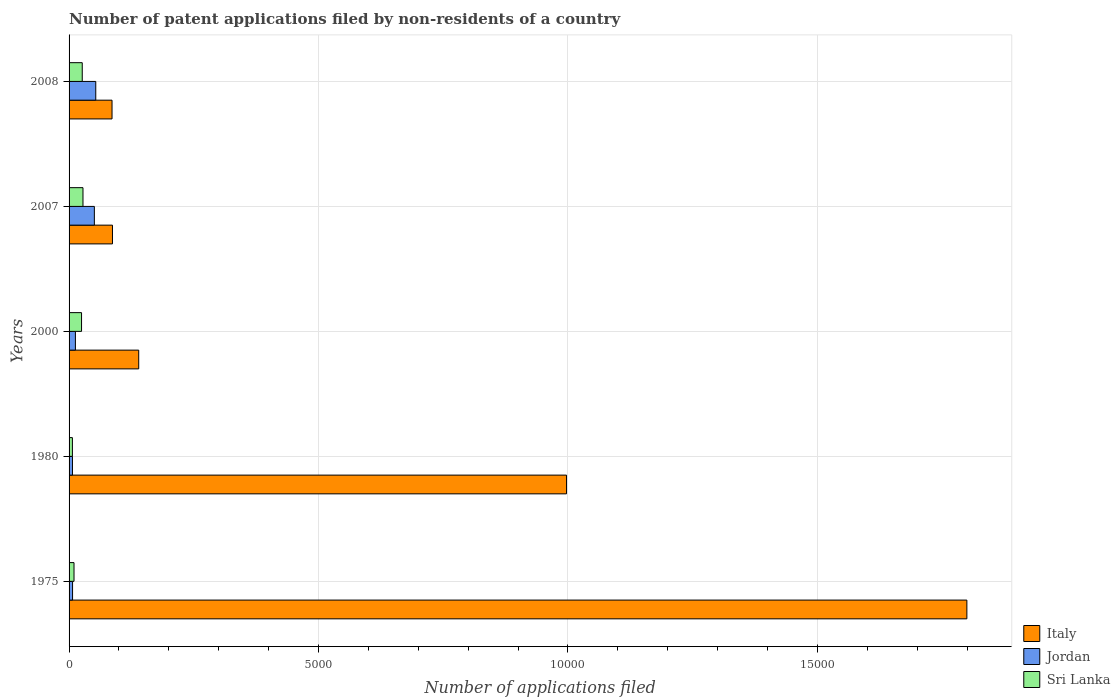How many groups of bars are there?
Ensure brevity in your answer.  5. Are the number of bars per tick equal to the number of legend labels?
Provide a short and direct response. Yes. Are the number of bars on each tick of the Y-axis equal?
Offer a very short reply. Yes. How many bars are there on the 1st tick from the top?
Provide a short and direct response. 3. How many bars are there on the 5th tick from the bottom?
Offer a terse response. 3. In how many cases, is the number of bars for a given year not equal to the number of legend labels?
Give a very brief answer. 0. What is the number of applications filed in Italy in 1980?
Give a very brief answer. 9971. Across all years, what is the maximum number of applications filed in Italy?
Offer a terse response. 1.80e+04. What is the total number of applications filed in Sri Lanka in the graph?
Provide a succinct answer. 959. What is the difference between the number of applications filed in Jordan in 1980 and that in 2007?
Offer a terse response. -439. What is the difference between the number of applications filed in Sri Lanka in 1980 and the number of applications filed in Italy in 1975?
Your answer should be very brief. -1.79e+04. What is the average number of applications filed in Sri Lanka per year?
Your answer should be very brief. 191.8. In the year 1975, what is the difference between the number of applications filed in Jordan and number of applications filed in Italy?
Give a very brief answer. -1.79e+04. In how many years, is the number of applications filed in Italy greater than 10000 ?
Your response must be concise. 1. What is the ratio of the number of applications filed in Jordan in 1975 to that in 1980?
Offer a terse response. 1.03. Is the number of applications filed in Sri Lanka in 1980 less than that in 2000?
Keep it short and to the point. Yes. What is the difference between the highest and the second highest number of applications filed in Sri Lanka?
Ensure brevity in your answer.  15. What is the difference between the highest and the lowest number of applications filed in Italy?
Your answer should be compact. 1.71e+04. In how many years, is the number of applications filed in Jordan greater than the average number of applications filed in Jordan taken over all years?
Give a very brief answer. 2. Is the sum of the number of applications filed in Sri Lanka in 2000 and 2008 greater than the maximum number of applications filed in Italy across all years?
Your response must be concise. No. What does the 2nd bar from the top in 2000 represents?
Give a very brief answer. Jordan. What does the 2nd bar from the bottom in 2007 represents?
Your answer should be very brief. Jordan. Is it the case that in every year, the sum of the number of applications filed in Jordan and number of applications filed in Italy is greater than the number of applications filed in Sri Lanka?
Ensure brevity in your answer.  Yes. How many bars are there?
Provide a short and direct response. 15. What is the difference between two consecutive major ticks on the X-axis?
Keep it short and to the point. 5000. How are the legend labels stacked?
Provide a short and direct response. Vertical. What is the title of the graph?
Provide a short and direct response. Number of patent applications filed by non-residents of a country. Does "Romania" appear as one of the legend labels in the graph?
Give a very brief answer. No. What is the label or title of the X-axis?
Make the answer very short. Number of applications filed. What is the label or title of the Y-axis?
Offer a terse response. Years. What is the Number of applications filed in Italy in 1975?
Offer a very short reply. 1.80e+04. What is the Number of applications filed in Jordan in 1975?
Provide a succinct answer. 70. What is the Number of applications filed in Italy in 1980?
Offer a terse response. 9971. What is the Number of applications filed of Sri Lanka in 1980?
Your response must be concise. 67. What is the Number of applications filed of Italy in 2000?
Provide a short and direct response. 1396. What is the Number of applications filed in Jordan in 2000?
Offer a terse response. 127. What is the Number of applications filed of Sri Lanka in 2000?
Keep it short and to the point. 250. What is the Number of applications filed in Italy in 2007?
Your answer should be compact. 870. What is the Number of applications filed in Jordan in 2007?
Your response must be concise. 507. What is the Number of applications filed of Sri Lanka in 2007?
Make the answer very short. 279. What is the Number of applications filed in Italy in 2008?
Provide a succinct answer. 861. What is the Number of applications filed of Jordan in 2008?
Offer a terse response. 535. What is the Number of applications filed of Sri Lanka in 2008?
Make the answer very short. 264. Across all years, what is the maximum Number of applications filed in Italy?
Make the answer very short. 1.80e+04. Across all years, what is the maximum Number of applications filed of Jordan?
Make the answer very short. 535. Across all years, what is the maximum Number of applications filed in Sri Lanka?
Ensure brevity in your answer.  279. Across all years, what is the minimum Number of applications filed in Italy?
Give a very brief answer. 861. Across all years, what is the minimum Number of applications filed of Jordan?
Ensure brevity in your answer.  68. What is the total Number of applications filed of Italy in the graph?
Your answer should be very brief. 3.11e+04. What is the total Number of applications filed in Jordan in the graph?
Keep it short and to the point. 1307. What is the total Number of applications filed in Sri Lanka in the graph?
Ensure brevity in your answer.  959. What is the difference between the Number of applications filed of Italy in 1975 and that in 1980?
Give a very brief answer. 8024. What is the difference between the Number of applications filed of Jordan in 1975 and that in 1980?
Keep it short and to the point. 2. What is the difference between the Number of applications filed of Italy in 1975 and that in 2000?
Your answer should be compact. 1.66e+04. What is the difference between the Number of applications filed in Jordan in 1975 and that in 2000?
Your answer should be compact. -57. What is the difference between the Number of applications filed in Sri Lanka in 1975 and that in 2000?
Your response must be concise. -151. What is the difference between the Number of applications filed of Italy in 1975 and that in 2007?
Keep it short and to the point. 1.71e+04. What is the difference between the Number of applications filed in Jordan in 1975 and that in 2007?
Your answer should be compact. -437. What is the difference between the Number of applications filed of Sri Lanka in 1975 and that in 2007?
Provide a succinct answer. -180. What is the difference between the Number of applications filed of Italy in 1975 and that in 2008?
Offer a very short reply. 1.71e+04. What is the difference between the Number of applications filed in Jordan in 1975 and that in 2008?
Offer a very short reply. -465. What is the difference between the Number of applications filed in Sri Lanka in 1975 and that in 2008?
Give a very brief answer. -165. What is the difference between the Number of applications filed of Italy in 1980 and that in 2000?
Keep it short and to the point. 8575. What is the difference between the Number of applications filed of Jordan in 1980 and that in 2000?
Provide a succinct answer. -59. What is the difference between the Number of applications filed in Sri Lanka in 1980 and that in 2000?
Keep it short and to the point. -183. What is the difference between the Number of applications filed of Italy in 1980 and that in 2007?
Your answer should be very brief. 9101. What is the difference between the Number of applications filed of Jordan in 1980 and that in 2007?
Keep it short and to the point. -439. What is the difference between the Number of applications filed in Sri Lanka in 1980 and that in 2007?
Offer a very short reply. -212. What is the difference between the Number of applications filed of Italy in 1980 and that in 2008?
Provide a succinct answer. 9110. What is the difference between the Number of applications filed of Jordan in 1980 and that in 2008?
Keep it short and to the point. -467. What is the difference between the Number of applications filed in Sri Lanka in 1980 and that in 2008?
Your response must be concise. -197. What is the difference between the Number of applications filed of Italy in 2000 and that in 2007?
Your answer should be very brief. 526. What is the difference between the Number of applications filed of Jordan in 2000 and that in 2007?
Keep it short and to the point. -380. What is the difference between the Number of applications filed in Sri Lanka in 2000 and that in 2007?
Offer a very short reply. -29. What is the difference between the Number of applications filed of Italy in 2000 and that in 2008?
Give a very brief answer. 535. What is the difference between the Number of applications filed in Jordan in 2000 and that in 2008?
Provide a succinct answer. -408. What is the difference between the Number of applications filed of Sri Lanka in 2000 and that in 2008?
Offer a very short reply. -14. What is the difference between the Number of applications filed in Sri Lanka in 2007 and that in 2008?
Give a very brief answer. 15. What is the difference between the Number of applications filed in Italy in 1975 and the Number of applications filed in Jordan in 1980?
Your answer should be compact. 1.79e+04. What is the difference between the Number of applications filed in Italy in 1975 and the Number of applications filed in Sri Lanka in 1980?
Keep it short and to the point. 1.79e+04. What is the difference between the Number of applications filed of Italy in 1975 and the Number of applications filed of Jordan in 2000?
Give a very brief answer. 1.79e+04. What is the difference between the Number of applications filed in Italy in 1975 and the Number of applications filed in Sri Lanka in 2000?
Ensure brevity in your answer.  1.77e+04. What is the difference between the Number of applications filed of Jordan in 1975 and the Number of applications filed of Sri Lanka in 2000?
Make the answer very short. -180. What is the difference between the Number of applications filed of Italy in 1975 and the Number of applications filed of Jordan in 2007?
Ensure brevity in your answer.  1.75e+04. What is the difference between the Number of applications filed of Italy in 1975 and the Number of applications filed of Sri Lanka in 2007?
Give a very brief answer. 1.77e+04. What is the difference between the Number of applications filed in Jordan in 1975 and the Number of applications filed in Sri Lanka in 2007?
Your answer should be very brief. -209. What is the difference between the Number of applications filed of Italy in 1975 and the Number of applications filed of Jordan in 2008?
Keep it short and to the point. 1.75e+04. What is the difference between the Number of applications filed of Italy in 1975 and the Number of applications filed of Sri Lanka in 2008?
Ensure brevity in your answer.  1.77e+04. What is the difference between the Number of applications filed in Jordan in 1975 and the Number of applications filed in Sri Lanka in 2008?
Give a very brief answer. -194. What is the difference between the Number of applications filed in Italy in 1980 and the Number of applications filed in Jordan in 2000?
Ensure brevity in your answer.  9844. What is the difference between the Number of applications filed in Italy in 1980 and the Number of applications filed in Sri Lanka in 2000?
Your answer should be very brief. 9721. What is the difference between the Number of applications filed in Jordan in 1980 and the Number of applications filed in Sri Lanka in 2000?
Keep it short and to the point. -182. What is the difference between the Number of applications filed in Italy in 1980 and the Number of applications filed in Jordan in 2007?
Your response must be concise. 9464. What is the difference between the Number of applications filed in Italy in 1980 and the Number of applications filed in Sri Lanka in 2007?
Your answer should be compact. 9692. What is the difference between the Number of applications filed of Jordan in 1980 and the Number of applications filed of Sri Lanka in 2007?
Offer a very short reply. -211. What is the difference between the Number of applications filed of Italy in 1980 and the Number of applications filed of Jordan in 2008?
Your response must be concise. 9436. What is the difference between the Number of applications filed of Italy in 1980 and the Number of applications filed of Sri Lanka in 2008?
Offer a very short reply. 9707. What is the difference between the Number of applications filed of Jordan in 1980 and the Number of applications filed of Sri Lanka in 2008?
Your response must be concise. -196. What is the difference between the Number of applications filed of Italy in 2000 and the Number of applications filed of Jordan in 2007?
Keep it short and to the point. 889. What is the difference between the Number of applications filed of Italy in 2000 and the Number of applications filed of Sri Lanka in 2007?
Your answer should be very brief. 1117. What is the difference between the Number of applications filed of Jordan in 2000 and the Number of applications filed of Sri Lanka in 2007?
Your answer should be compact. -152. What is the difference between the Number of applications filed in Italy in 2000 and the Number of applications filed in Jordan in 2008?
Give a very brief answer. 861. What is the difference between the Number of applications filed in Italy in 2000 and the Number of applications filed in Sri Lanka in 2008?
Your answer should be very brief. 1132. What is the difference between the Number of applications filed in Jordan in 2000 and the Number of applications filed in Sri Lanka in 2008?
Offer a very short reply. -137. What is the difference between the Number of applications filed in Italy in 2007 and the Number of applications filed in Jordan in 2008?
Your answer should be compact. 335. What is the difference between the Number of applications filed in Italy in 2007 and the Number of applications filed in Sri Lanka in 2008?
Keep it short and to the point. 606. What is the difference between the Number of applications filed in Jordan in 2007 and the Number of applications filed in Sri Lanka in 2008?
Your answer should be very brief. 243. What is the average Number of applications filed in Italy per year?
Make the answer very short. 6218.6. What is the average Number of applications filed in Jordan per year?
Ensure brevity in your answer.  261.4. What is the average Number of applications filed in Sri Lanka per year?
Provide a succinct answer. 191.8. In the year 1975, what is the difference between the Number of applications filed of Italy and Number of applications filed of Jordan?
Your answer should be very brief. 1.79e+04. In the year 1975, what is the difference between the Number of applications filed of Italy and Number of applications filed of Sri Lanka?
Keep it short and to the point. 1.79e+04. In the year 1975, what is the difference between the Number of applications filed of Jordan and Number of applications filed of Sri Lanka?
Provide a short and direct response. -29. In the year 1980, what is the difference between the Number of applications filed of Italy and Number of applications filed of Jordan?
Offer a very short reply. 9903. In the year 1980, what is the difference between the Number of applications filed in Italy and Number of applications filed in Sri Lanka?
Offer a terse response. 9904. In the year 1980, what is the difference between the Number of applications filed of Jordan and Number of applications filed of Sri Lanka?
Offer a terse response. 1. In the year 2000, what is the difference between the Number of applications filed of Italy and Number of applications filed of Jordan?
Your answer should be very brief. 1269. In the year 2000, what is the difference between the Number of applications filed of Italy and Number of applications filed of Sri Lanka?
Give a very brief answer. 1146. In the year 2000, what is the difference between the Number of applications filed of Jordan and Number of applications filed of Sri Lanka?
Provide a short and direct response. -123. In the year 2007, what is the difference between the Number of applications filed in Italy and Number of applications filed in Jordan?
Your answer should be very brief. 363. In the year 2007, what is the difference between the Number of applications filed of Italy and Number of applications filed of Sri Lanka?
Offer a terse response. 591. In the year 2007, what is the difference between the Number of applications filed in Jordan and Number of applications filed in Sri Lanka?
Make the answer very short. 228. In the year 2008, what is the difference between the Number of applications filed of Italy and Number of applications filed of Jordan?
Your response must be concise. 326. In the year 2008, what is the difference between the Number of applications filed of Italy and Number of applications filed of Sri Lanka?
Keep it short and to the point. 597. In the year 2008, what is the difference between the Number of applications filed in Jordan and Number of applications filed in Sri Lanka?
Your answer should be very brief. 271. What is the ratio of the Number of applications filed in Italy in 1975 to that in 1980?
Give a very brief answer. 1.8. What is the ratio of the Number of applications filed in Jordan in 1975 to that in 1980?
Provide a succinct answer. 1.03. What is the ratio of the Number of applications filed in Sri Lanka in 1975 to that in 1980?
Offer a very short reply. 1.48. What is the ratio of the Number of applications filed of Italy in 1975 to that in 2000?
Your answer should be compact. 12.89. What is the ratio of the Number of applications filed in Jordan in 1975 to that in 2000?
Give a very brief answer. 0.55. What is the ratio of the Number of applications filed of Sri Lanka in 1975 to that in 2000?
Your answer should be compact. 0.4. What is the ratio of the Number of applications filed of Italy in 1975 to that in 2007?
Ensure brevity in your answer.  20.68. What is the ratio of the Number of applications filed in Jordan in 1975 to that in 2007?
Keep it short and to the point. 0.14. What is the ratio of the Number of applications filed in Sri Lanka in 1975 to that in 2007?
Make the answer very short. 0.35. What is the ratio of the Number of applications filed of Italy in 1975 to that in 2008?
Your answer should be compact. 20.9. What is the ratio of the Number of applications filed of Jordan in 1975 to that in 2008?
Your answer should be compact. 0.13. What is the ratio of the Number of applications filed in Italy in 1980 to that in 2000?
Your answer should be compact. 7.14. What is the ratio of the Number of applications filed in Jordan in 1980 to that in 2000?
Offer a very short reply. 0.54. What is the ratio of the Number of applications filed of Sri Lanka in 1980 to that in 2000?
Offer a terse response. 0.27. What is the ratio of the Number of applications filed of Italy in 1980 to that in 2007?
Your answer should be very brief. 11.46. What is the ratio of the Number of applications filed in Jordan in 1980 to that in 2007?
Keep it short and to the point. 0.13. What is the ratio of the Number of applications filed in Sri Lanka in 1980 to that in 2007?
Offer a terse response. 0.24. What is the ratio of the Number of applications filed of Italy in 1980 to that in 2008?
Give a very brief answer. 11.58. What is the ratio of the Number of applications filed in Jordan in 1980 to that in 2008?
Offer a very short reply. 0.13. What is the ratio of the Number of applications filed of Sri Lanka in 1980 to that in 2008?
Keep it short and to the point. 0.25. What is the ratio of the Number of applications filed in Italy in 2000 to that in 2007?
Your response must be concise. 1.6. What is the ratio of the Number of applications filed of Jordan in 2000 to that in 2007?
Your response must be concise. 0.25. What is the ratio of the Number of applications filed of Sri Lanka in 2000 to that in 2007?
Provide a short and direct response. 0.9. What is the ratio of the Number of applications filed in Italy in 2000 to that in 2008?
Your answer should be very brief. 1.62. What is the ratio of the Number of applications filed in Jordan in 2000 to that in 2008?
Keep it short and to the point. 0.24. What is the ratio of the Number of applications filed in Sri Lanka in 2000 to that in 2008?
Ensure brevity in your answer.  0.95. What is the ratio of the Number of applications filed of Italy in 2007 to that in 2008?
Offer a terse response. 1.01. What is the ratio of the Number of applications filed in Jordan in 2007 to that in 2008?
Provide a succinct answer. 0.95. What is the ratio of the Number of applications filed in Sri Lanka in 2007 to that in 2008?
Provide a short and direct response. 1.06. What is the difference between the highest and the second highest Number of applications filed of Italy?
Your answer should be very brief. 8024. What is the difference between the highest and the lowest Number of applications filed of Italy?
Your answer should be very brief. 1.71e+04. What is the difference between the highest and the lowest Number of applications filed of Jordan?
Provide a short and direct response. 467. What is the difference between the highest and the lowest Number of applications filed of Sri Lanka?
Your answer should be compact. 212. 